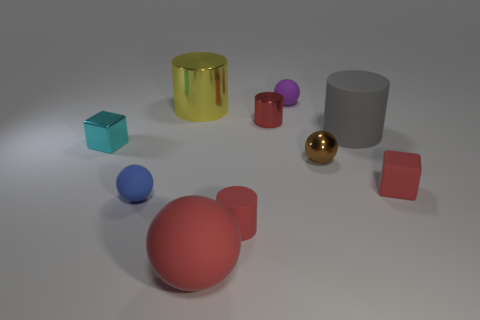What color is the big cylinder on the left side of the big thing in front of the big rubber thing to the right of the red sphere?
Keep it short and to the point. Yellow. What number of metal things are both in front of the large yellow shiny cylinder and left of the tiny brown metallic object?
Ensure brevity in your answer.  2. What number of blocks are brown objects or tiny blue rubber things?
Your answer should be very brief. 0. Are there any tiny cyan blocks?
Your answer should be very brief. Yes. What number of other things are there of the same material as the big gray cylinder
Make the answer very short. 5. There is a red object that is the same size as the gray rubber cylinder; what material is it?
Give a very brief answer. Rubber. There is a large rubber thing that is right of the small purple matte object; is it the same shape as the small blue matte thing?
Make the answer very short. No. Do the tiny matte cylinder and the metallic cube have the same color?
Offer a very short reply. No. How many things are either metal things that are on the left side of the big ball or gray rubber objects?
Provide a short and direct response. 3. What is the shape of the red shiny thing that is the same size as the red matte cube?
Offer a very short reply. Cylinder. 